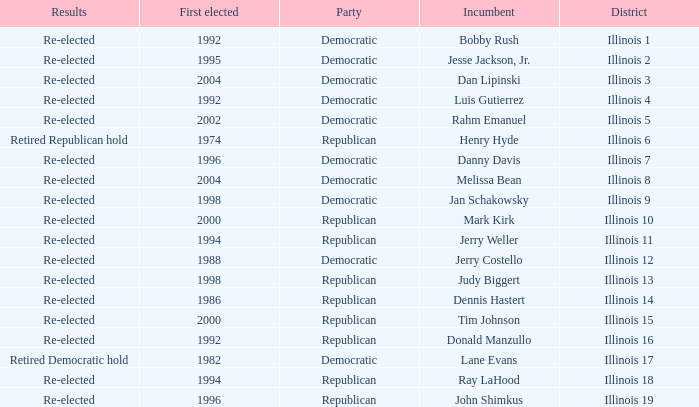What is the First Elected date of the Republican with Results of retired republican hold? 1974.0. Would you be able to parse every entry in this table? {'header': ['Results', 'First elected', 'Party', 'Incumbent', 'District'], 'rows': [['Re-elected', '1992', 'Democratic', 'Bobby Rush', 'Illinois 1'], ['Re-elected', '1995', 'Democratic', 'Jesse Jackson, Jr.', 'Illinois 2'], ['Re-elected', '2004', 'Democratic', 'Dan Lipinski', 'Illinois 3'], ['Re-elected', '1992', 'Democratic', 'Luis Gutierrez', 'Illinois 4'], ['Re-elected', '2002', 'Democratic', 'Rahm Emanuel', 'Illinois 5'], ['Retired Republican hold', '1974', 'Republican', 'Henry Hyde', 'Illinois 6'], ['Re-elected', '1996', 'Democratic', 'Danny Davis', 'Illinois 7'], ['Re-elected', '2004', 'Democratic', 'Melissa Bean', 'Illinois 8'], ['Re-elected', '1998', 'Democratic', 'Jan Schakowsky', 'Illinois 9'], ['Re-elected', '2000', 'Republican', 'Mark Kirk', 'Illinois 10'], ['Re-elected', '1994', 'Republican', 'Jerry Weller', 'Illinois 11'], ['Re-elected', '1988', 'Democratic', 'Jerry Costello', 'Illinois 12'], ['Re-elected', '1998', 'Republican', 'Judy Biggert', 'Illinois 13'], ['Re-elected', '1986', 'Republican', 'Dennis Hastert', 'Illinois 14'], ['Re-elected', '2000', 'Republican', 'Tim Johnson', 'Illinois 15'], ['Re-elected', '1992', 'Republican', 'Donald Manzullo', 'Illinois 16'], ['Retired Democratic hold', '1982', 'Democratic', 'Lane Evans', 'Illinois 17'], ['Re-elected', '1994', 'Republican', 'Ray LaHood', 'Illinois 18'], ['Re-elected', '1996', 'Republican', 'John Shimkus', 'Illinois 19']]} 